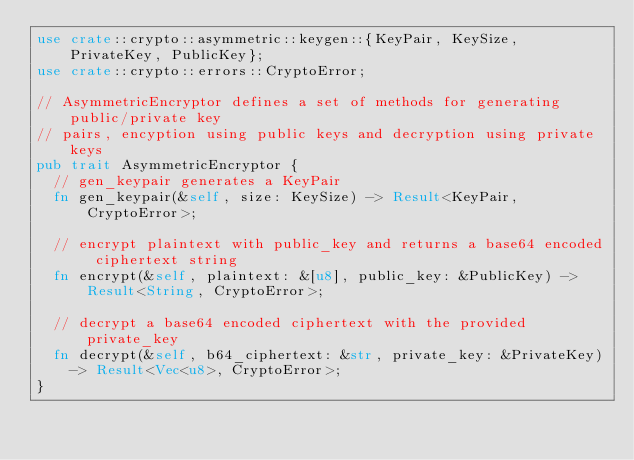Convert code to text. <code><loc_0><loc_0><loc_500><loc_500><_Rust_>use crate::crypto::asymmetric::keygen::{KeyPair, KeySize, PrivateKey, PublicKey};
use crate::crypto::errors::CryptoError;

// AsymmetricEncryptor defines a set of methods for generating public/private key
// pairs, encyption using public keys and decryption using private keys
pub trait AsymmetricEncryptor {
  // gen_keypair generates a KeyPair
  fn gen_keypair(&self, size: KeySize) -> Result<KeyPair, CryptoError>;

  // encrypt plaintext with public_key and returns a base64 encoded ciphertext string
  fn encrypt(&self, plaintext: &[u8], public_key: &PublicKey) -> Result<String, CryptoError>;

  // decrypt a base64 encoded ciphertext with the provided private_key
  fn decrypt(&self, b64_ciphertext: &str, private_key: &PrivateKey)
    -> Result<Vec<u8>, CryptoError>;
}
</code> 